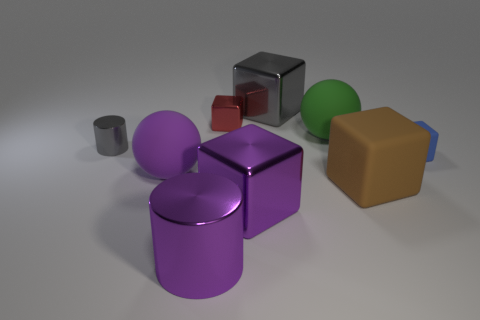Subtract 1 blocks. How many blocks are left? 4 Subtract all blue blocks. How many blocks are left? 4 Subtract all small rubber blocks. How many blocks are left? 4 Subtract all cyan cubes. Subtract all red cylinders. How many cubes are left? 5 Add 1 large gray blocks. How many objects exist? 10 Subtract all spheres. How many objects are left? 7 Add 3 green rubber objects. How many green rubber objects exist? 4 Subtract 0 yellow spheres. How many objects are left? 9 Subtract all big green shiny blocks. Subtract all cubes. How many objects are left? 4 Add 3 purple things. How many purple things are left? 6 